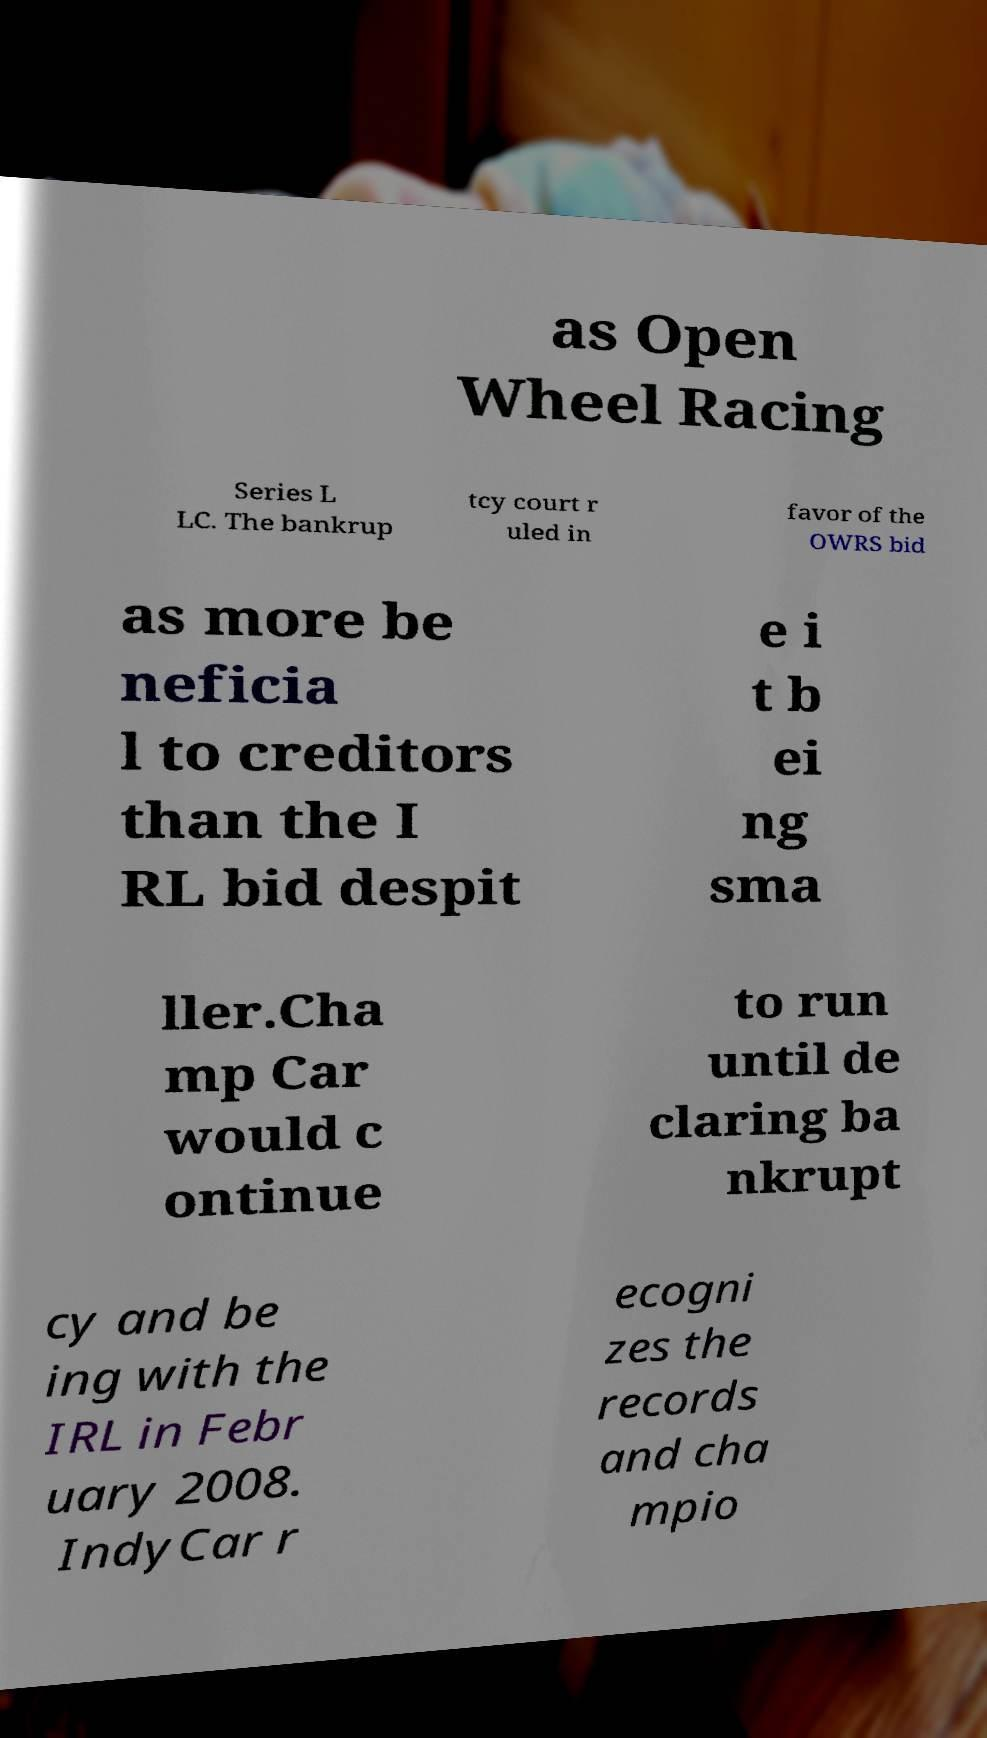Could you assist in decoding the text presented in this image and type it out clearly? as Open Wheel Racing Series L LC. The bankrup tcy court r uled in favor of the OWRS bid as more be neficia l to creditors than the I RL bid despit e i t b ei ng sma ller.Cha mp Car would c ontinue to run until de claring ba nkrupt cy and be ing with the IRL in Febr uary 2008. IndyCar r ecogni zes the records and cha mpio 